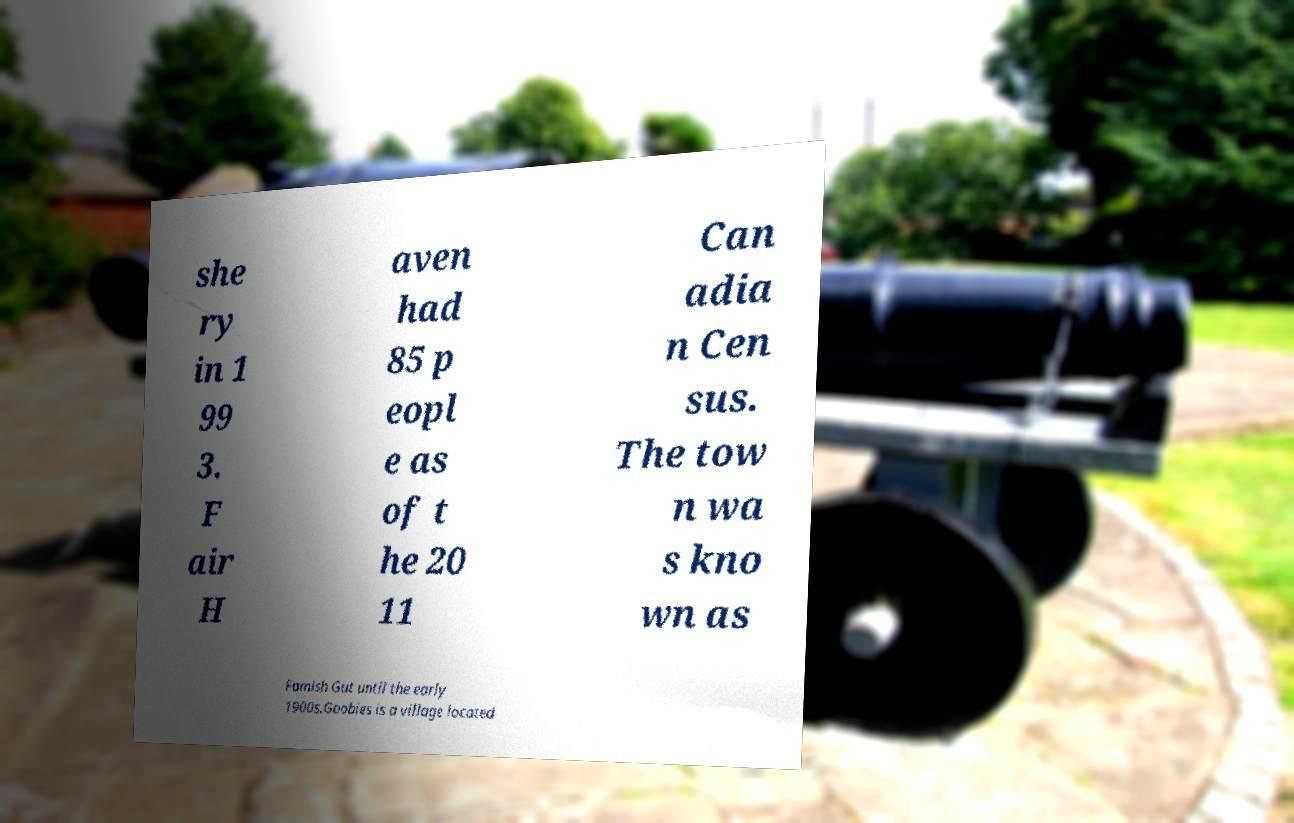For documentation purposes, I need the text within this image transcribed. Could you provide that? she ry in 1 99 3. F air H aven had 85 p eopl e as of t he 20 11 Can adia n Cen sus. The tow n wa s kno wn as Famish Gut until the early 1900s.Goobies is a village located 